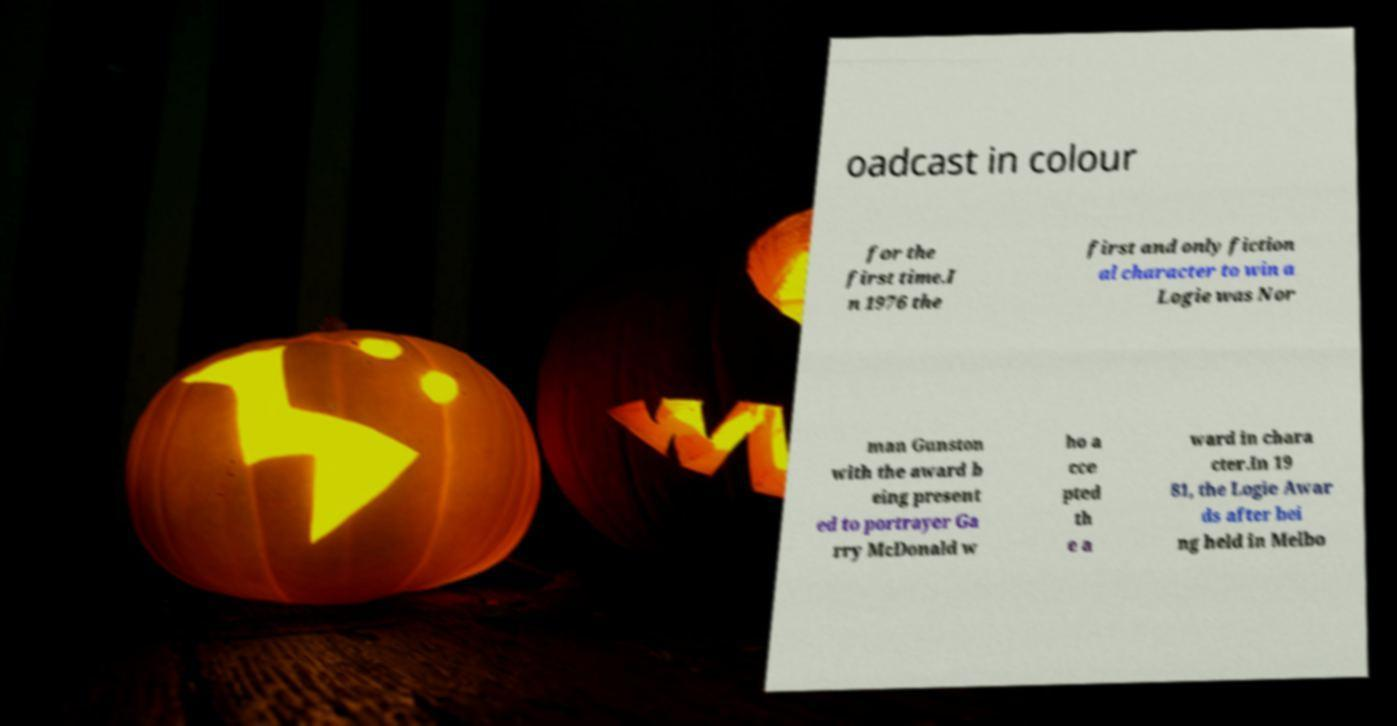Can you read and provide the text displayed in the image?This photo seems to have some interesting text. Can you extract and type it out for me? oadcast in colour for the first time.I n 1976 the first and only fiction al character to win a Logie was Nor man Gunston with the award b eing present ed to portrayer Ga rry McDonald w ho a cce pted th e a ward in chara cter.In 19 81, the Logie Awar ds after bei ng held in Melbo 